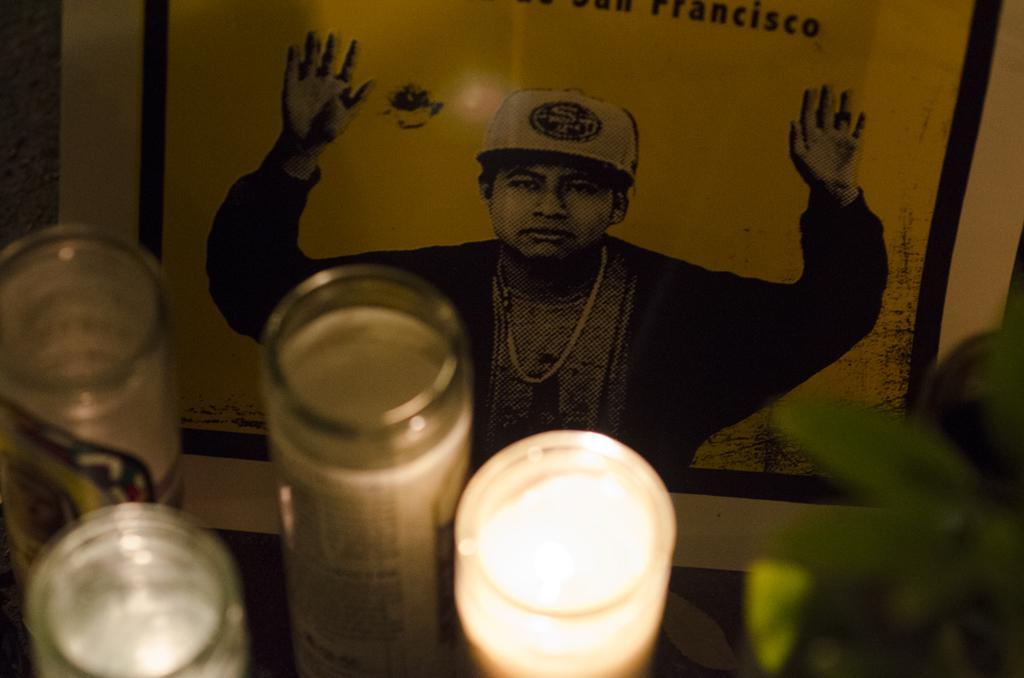Describe this image in one or two sentences. At the bottom of the image, we can see light, glass objects and leaves. In the background, we can see a poster. On this poster, we can see a person and text. 